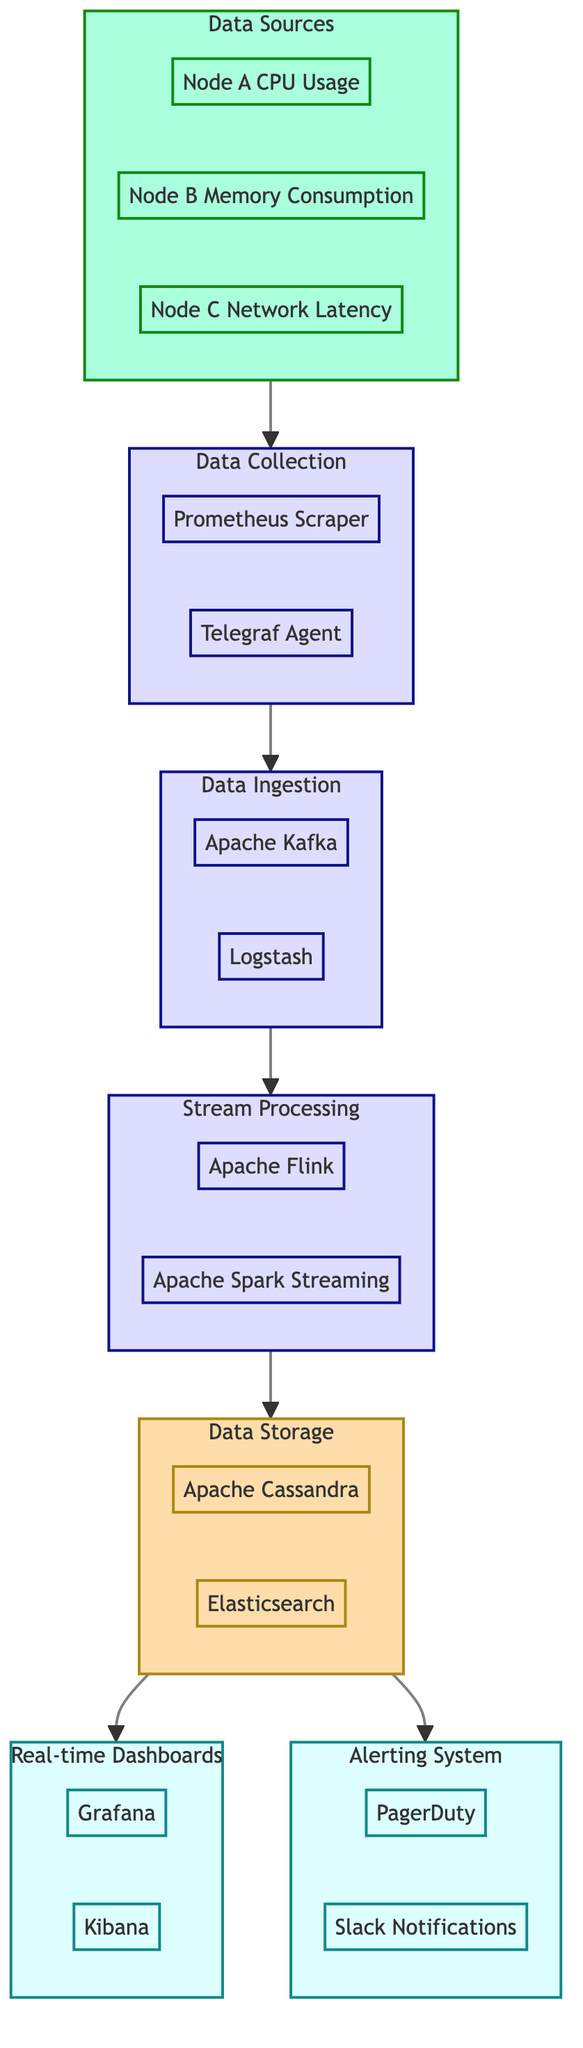What are the data sources in the pipeline? The diagram lists three data sources: Node A CPU Usage, Node B Memory Consumption, and Node C Network Latency under the "Data Sources" subgraph.
Answer: Node A CPU Usage, Node B Memory Consumption, Node C Network Latency How many components are used for data collection? The "Data Collection" subgraph shows two components: Prometheus Scraper and Telegraf Agent. Thus, the count is determined by simply counting the entities in that subgraph.
Answer: 2 Which tools are involved in data ingestion? In the "Data Ingestion" subgraph, the tools are listed as Apache Kafka and Logstash. This is obtained by identifying the contents of that specific subgraph.
Answer: Apache Kafka, Logstash What types of databases are used for data storage? The "Data Storage" subgraph contains two databases: Apache Cassandra and Elasticsearch. By focusing on that section, we can determine the specific types employed for storage.
Answer: Apache Cassandra, Elasticsearch What is the flow from data collection to real-time dashboards? The flow starts from "Data Collection," going to "Data Ingestion," then to "Stream Processing," followed by "Data Storage," and finally leading to "Real-time Dashboards." Tracing the arrows shows this progression through the elements of the diagram.
Answer: Data Collection → Data Ingestion → Stream Processing → Data Storage → Real-time Dashboards How many output elements are there in the diagram? The diagram identifies two output elements: Real-time Dashboards and Alerting System. By simply counting the distinct elements under the output categories in the subgraphs, we get the total.
Answer: 2 What framework is used for stream processing? The "Stream Processing" subgraph names two frameworks: Apache Flink and Apache Spark Streaming. Identifying the frameworks listed in that subgraph provides the answer.
Answer: Apache Flink, Apache Spark Streaming Which services notify stakeholders in the alerting system? The "Alerting System" subgraph outlines two services: PagerDuty and Slack Notifications. This is determined by looking at which services are specifically mentioned in that section.
Answer: PagerDuty, Slack Notifications What is the primary purpose of real-time dashboards? The description under "Real-time Dashboards" states that their purpose is to visualize real-time analysis of application performance, articulating that their function is for visual representation of analytics.
Answer: Visualizing real-time analysis of application performance 